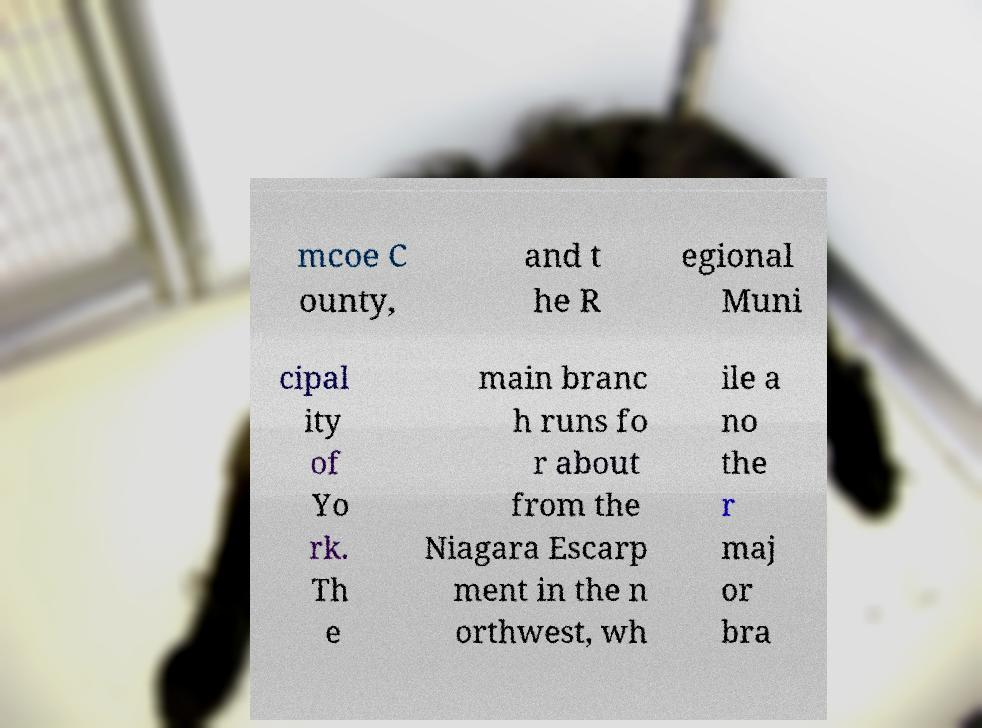Can you read and provide the text displayed in the image?This photo seems to have some interesting text. Can you extract and type it out for me? mcoe C ounty, and t he R egional Muni cipal ity of Yo rk. Th e main branc h runs fo r about from the Niagara Escarp ment in the n orthwest, wh ile a no the r maj or bra 